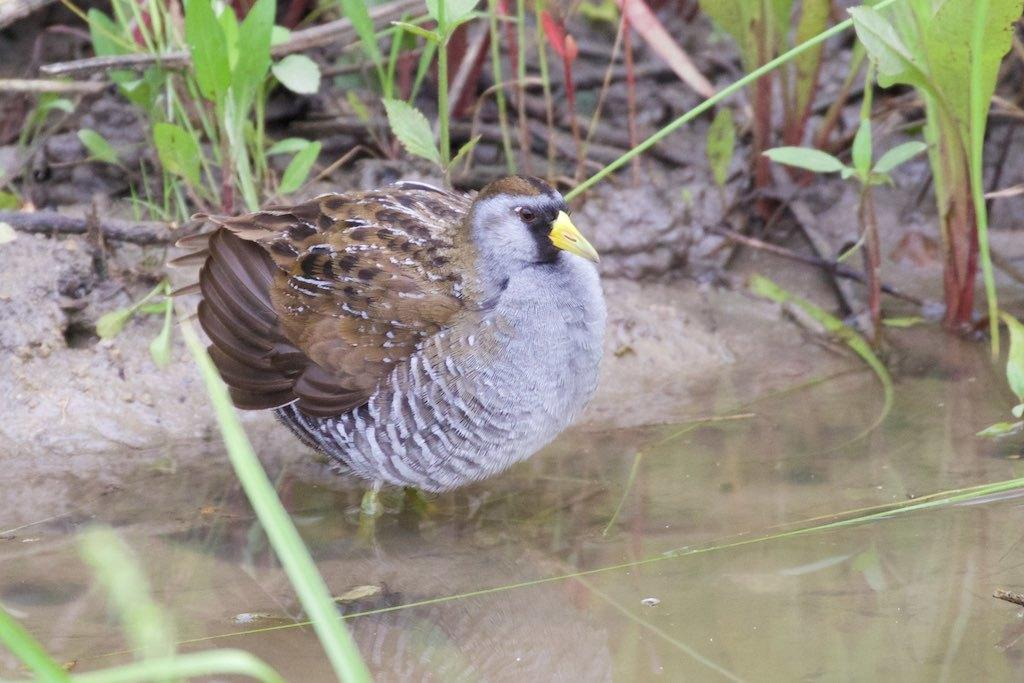What type of animal can be seen in the image? There is a bird in the image. What is the primary element in which the bird is situated? There is water visible in the image, and the bird is likely in or near the water. What can be seen in the background of the image? There are plants and sticks in the background of the image. What type of polish is being applied to the bird's stem in the image? There is no bird with a stem in the image, nor is any polish being applied. 